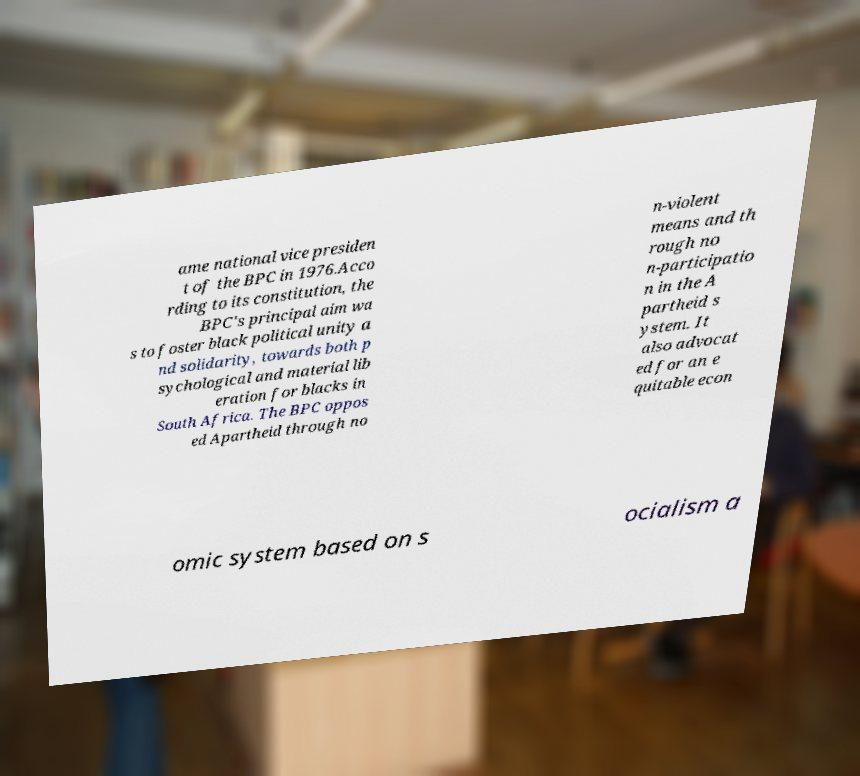Please read and relay the text visible in this image. What does it say? ame national vice presiden t of the BPC in 1976.Acco rding to its constitution, the BPC's principal aim wa s to foster black political unity a nd solidarity, towards both p sychological and material lib eration for blacks in South Africa. The BPC oppos ed Apartheid through no n-violent means and th rough no n-participatio n in the A partheid s ystem. It also advocat ed for an e quitable econ omic system based on s ocialism a 